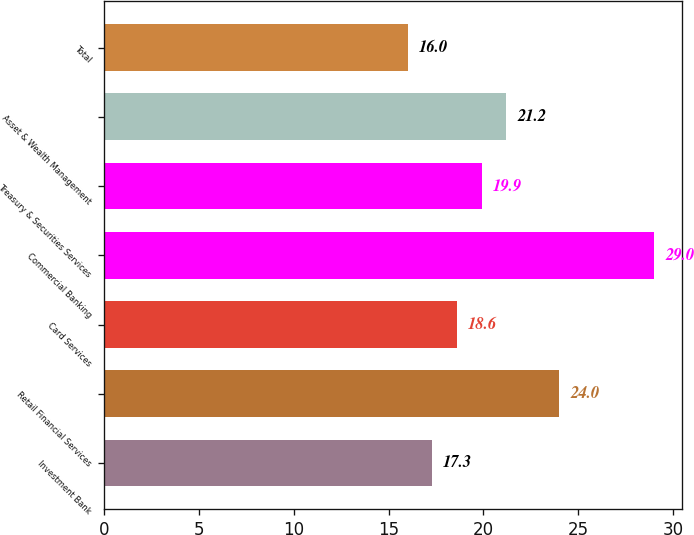Convert chart to OTSL. <chart><loc_0><loc_0><loc_500><loc_500><bar_chart><fcel>Investment Bank<fcel>Retail Financial Services<fcel>Card Services<fcel>Commercial Banking<fcel>Treasury & Securities Services<fcel>Asset & Wealth Management<fcel>Total<nl><fcel>17.3<fcel>24<fcel>18.6<fcel>29<fcel>19.9<fcel>21.2<fcel>16<nl></chart> 